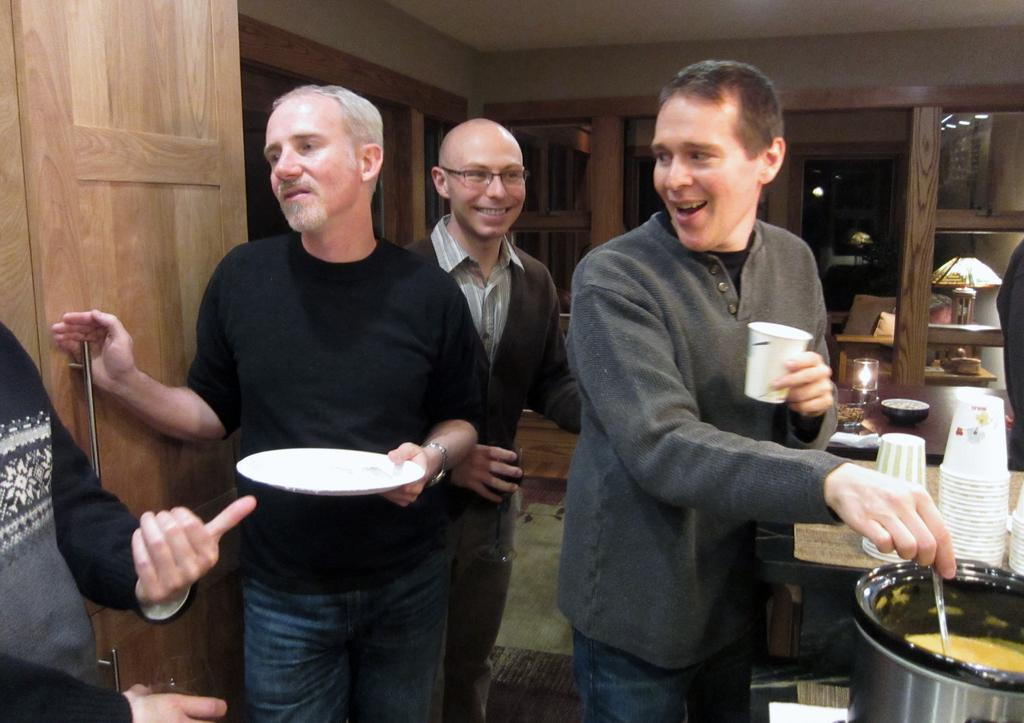What can be seen in the image involving people? There are people standing in the image. What is located on the right side of the image? There is a container and glasses on the right side of the image. What type of door is visible on the left side of the image? There is a wooden door on the left side of the image. What type of bun is being used to make a discovery in the image? There is no bun or discovery present in the image. Can you describe the stranger in the image? There is no stranger present in the image; it only shows people standing. 